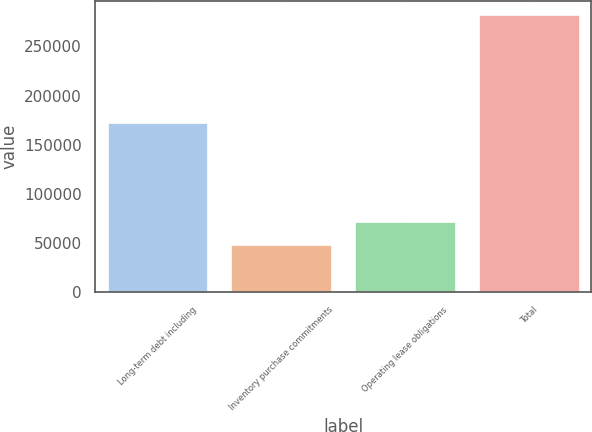<chart> <loc_0><loc_0><loc_500><loc_500><bar_chart><fcel>Long-term debt including<fcel>Inventory purchase commitments<fcel>Operating lease obligations<fcel>Total<nl><fcel>171799<fcel>48139<fcel>71488.4<fcel>281633<nl></chart> 